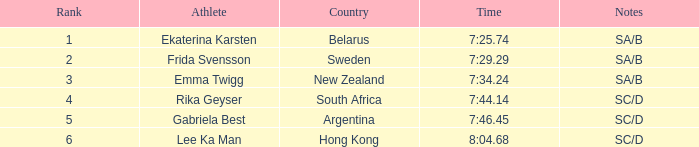What is the total rank for the athlete that had a race time of 7:34.24? 1.0. 